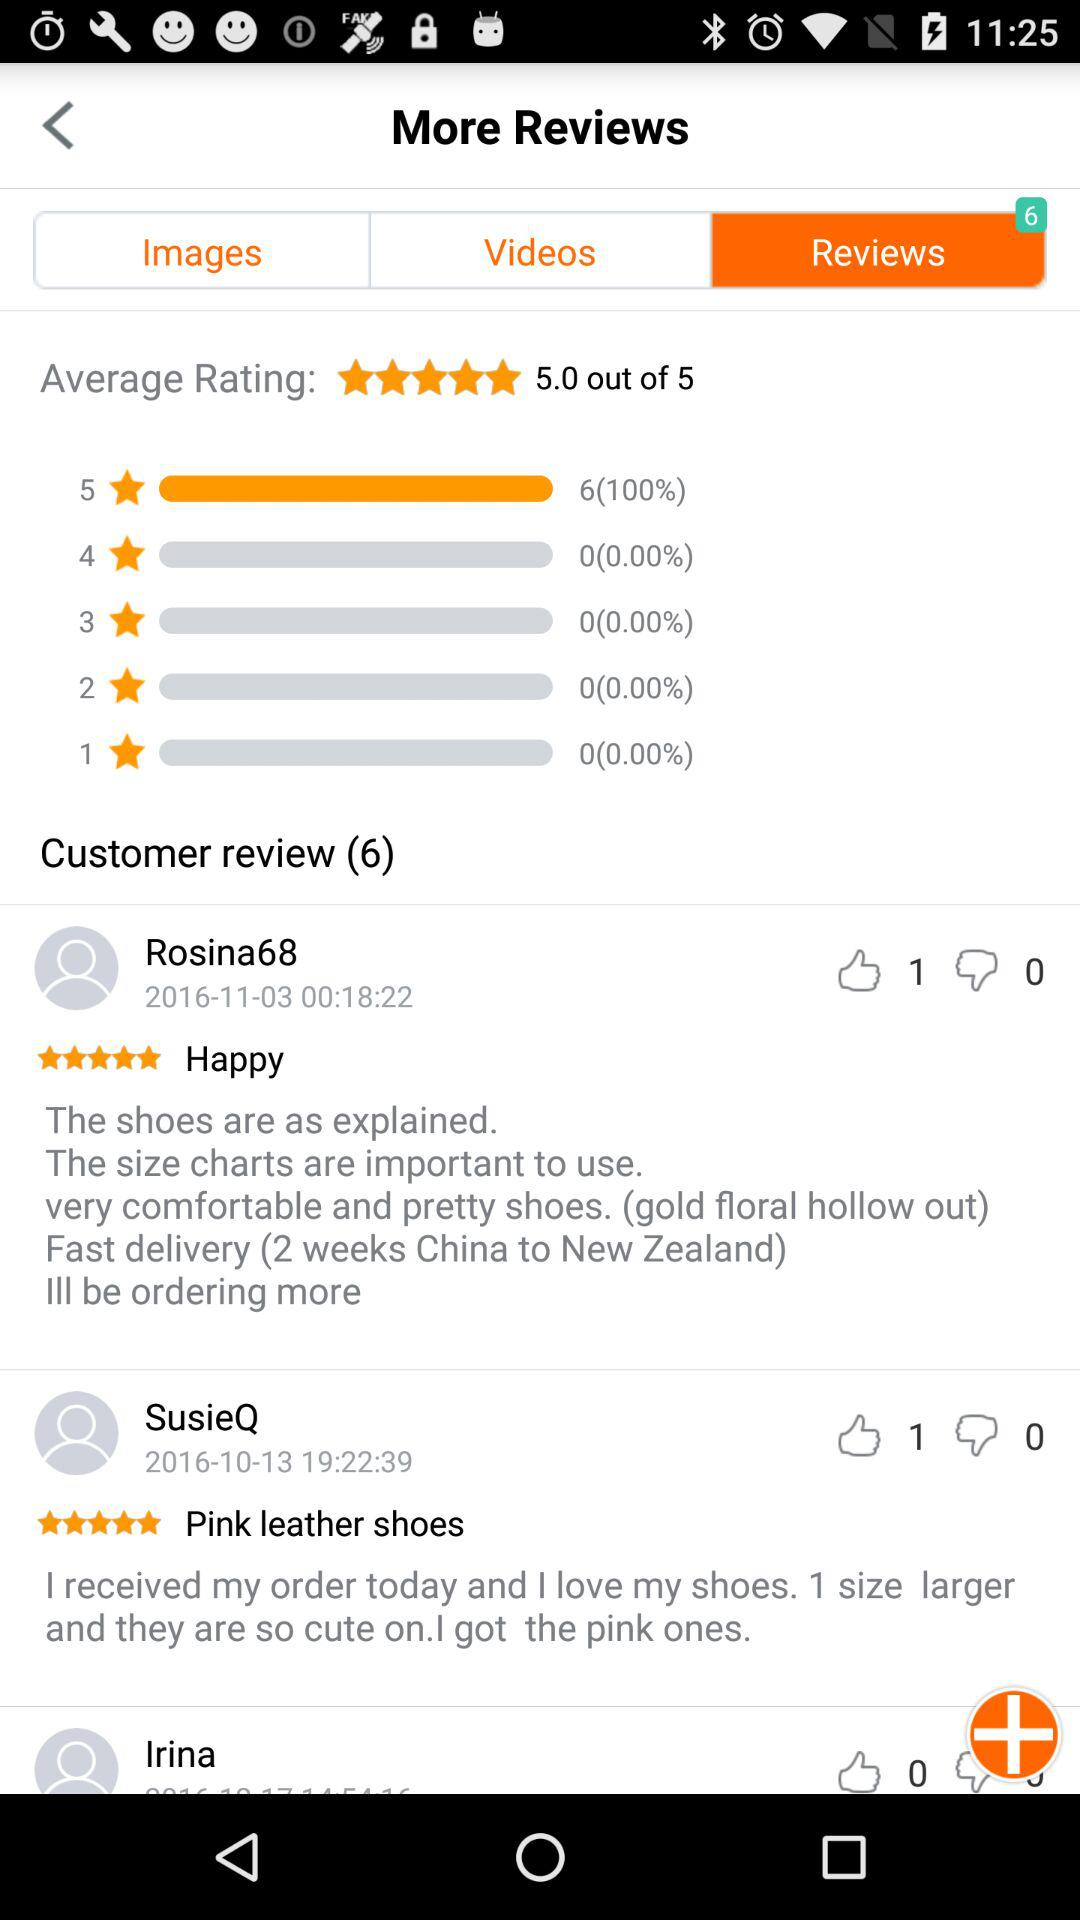How much is the average rating? The average rating is 5. 